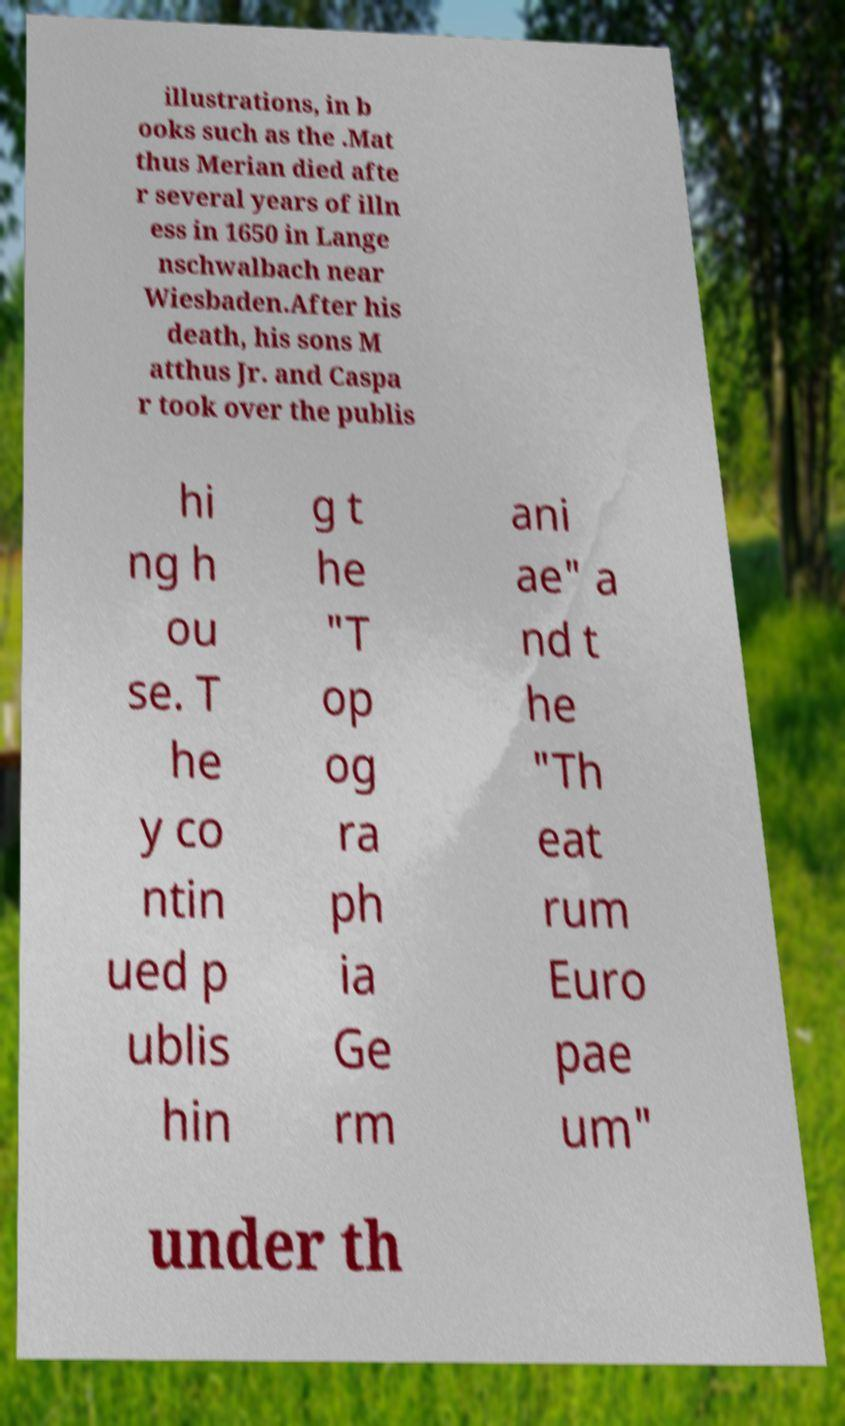There's text embedded in this image that I need extracted. Can you transcribe it verbatim? illustrations, in b ooks such as the .Mat thus Merian died afte r several years of illn ess in 1650 in Lange nschwalbach near Wiesbaden.After his death, his sons M atthus Jr. and Caspa r took over the publis hi ng h ou se. T he y co ntin ued p ublis hin g t he "T op og ra ph ia Ge rm ani ae" a nd t he "Th eat rum Euro pae um" under th 